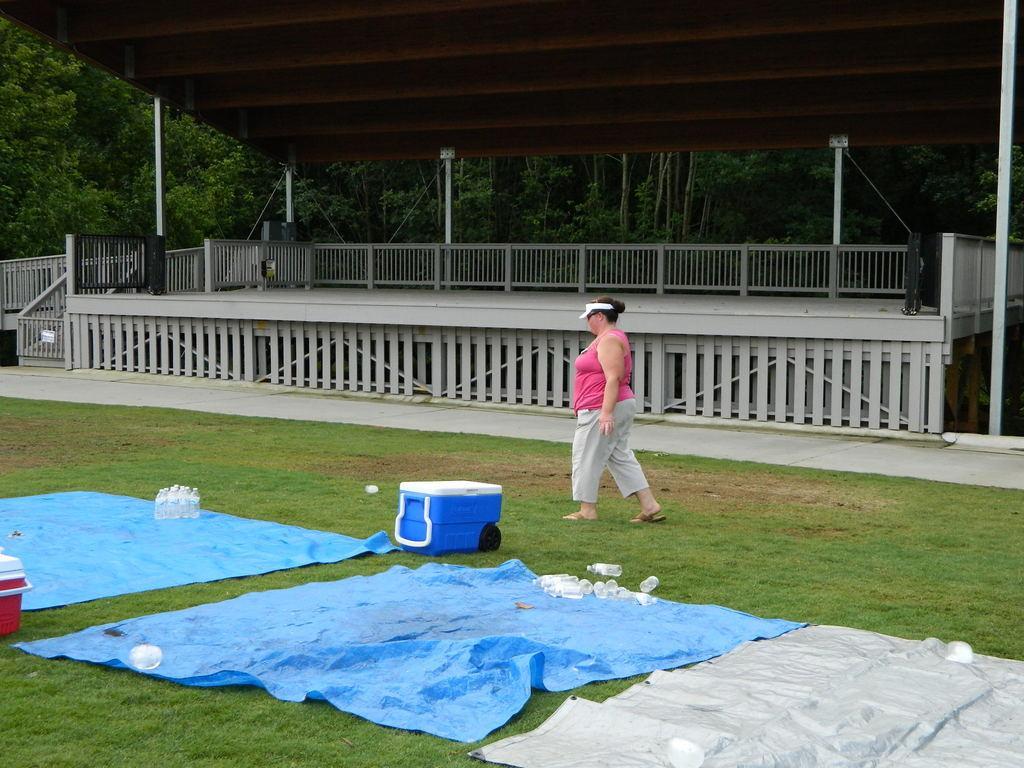In one or two sentences, can you explain what this image depicts? A person is walking wearing a pink t shirt and a trouser. There are plastic mats and plastic bottles. At the back there is fencing and trees. 